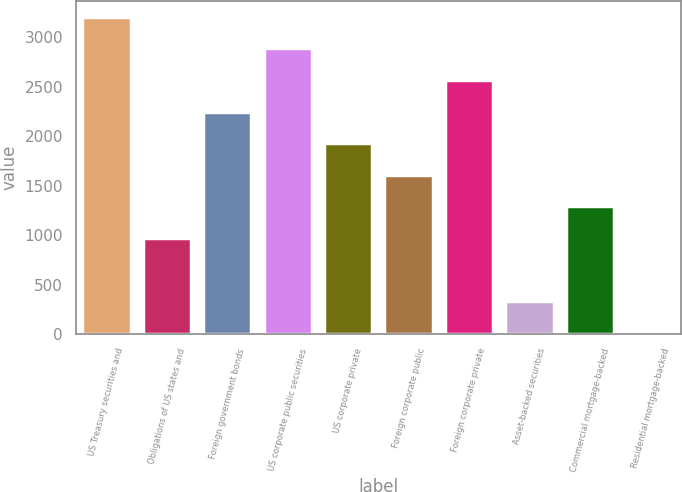Convert chart to OTSL. <chart><loc_0><loc_0><loc_500><loc_500><bar_chart><fcel>US Treasury securities and<fcel>Obligations of US states and<fcel>Foreign government bonds<fcel>US corporate public securities<fcel>US corporate private<fcel>Foreign corporate public<fcel>Foreign corporate private<fcel>Asset-backed securities<fcel>Commercial mortgage-backed<fcel>Residential mortgage-backed<nl><fcel>3205<fcel>969.9<fcel>2247.1<fcel>2885.7<fcel>1927.8<fcel>1608.5<fcel>2566.4<fcel>331.3<fcel>1289.2<fcel>12<nl></chart> 